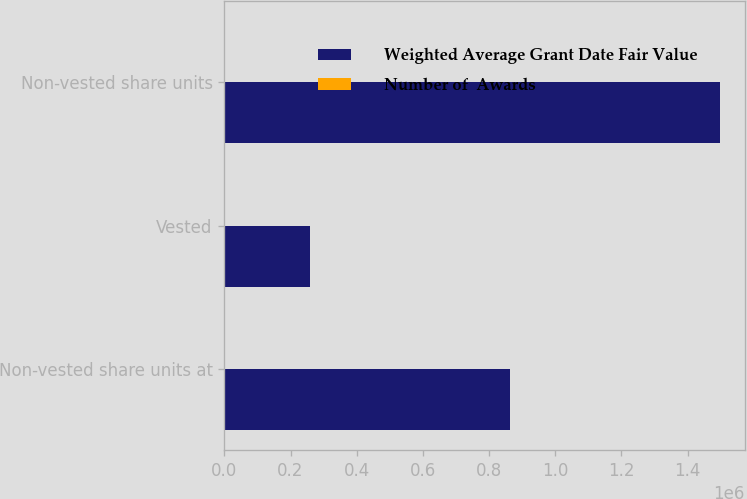Convert chart to OTSL. <chart><loc_0><loc_0><loc_500><loc_500><stacked_bar_chart><ecel><fcel>Non-vested share units at<fcel>Vested<fcel>Non-vested share units<nl><fcel>Weighted Average Grant Date Fair Value<fcel>862734<fcel>259291<fcel>1.49822e+06<nl><fcel>Number of  Awards<fcel>36.24<fcel>38.26<fcel>18.26<nl></chart> 